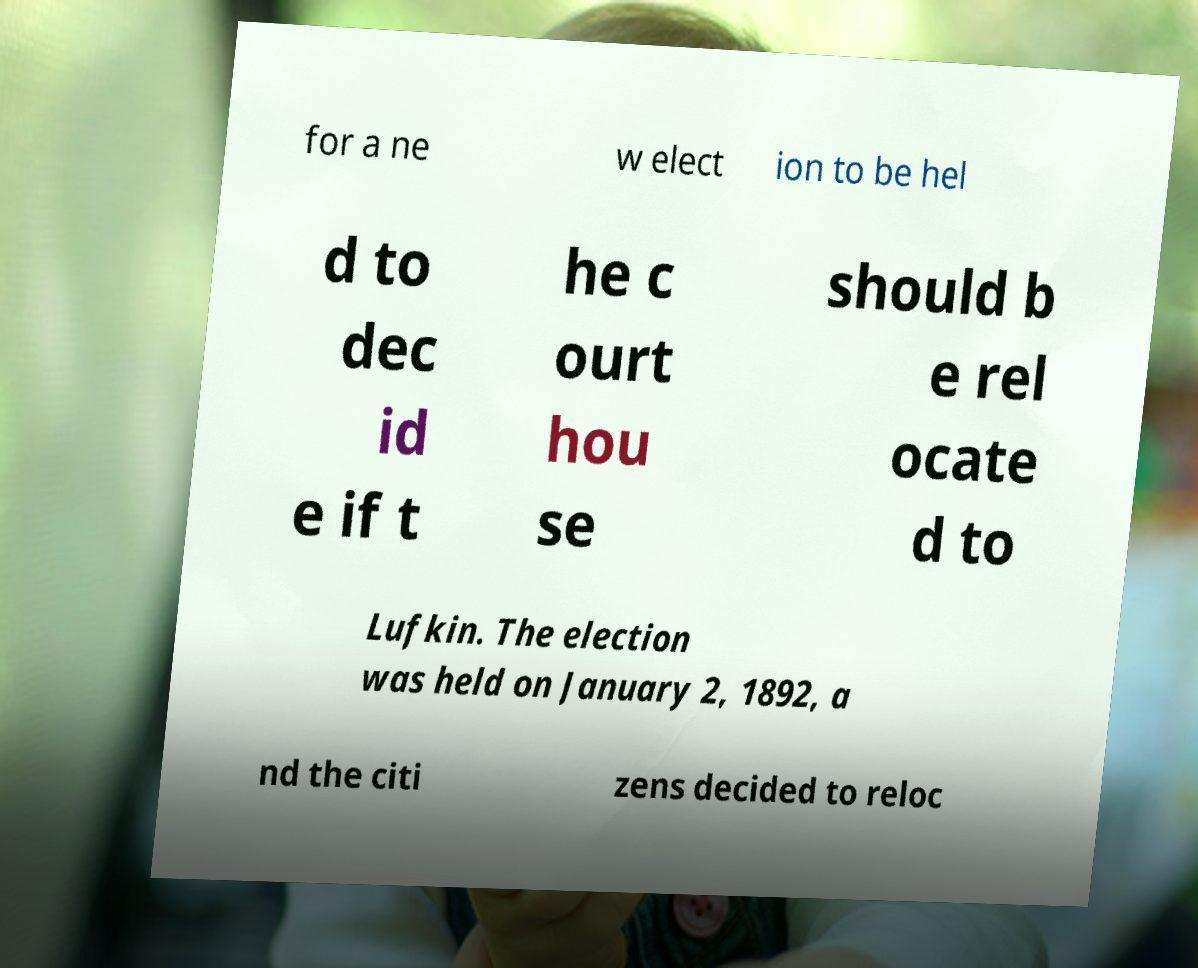Can you accurately transcribe the text from the provided image for me? for a ne w elect ion to be hel d to dec id e if t he c ourt hou se should b e rel ocate d to Lufkin. The election was held on January 2, 1892, a nd the citi zens decided to reloc 